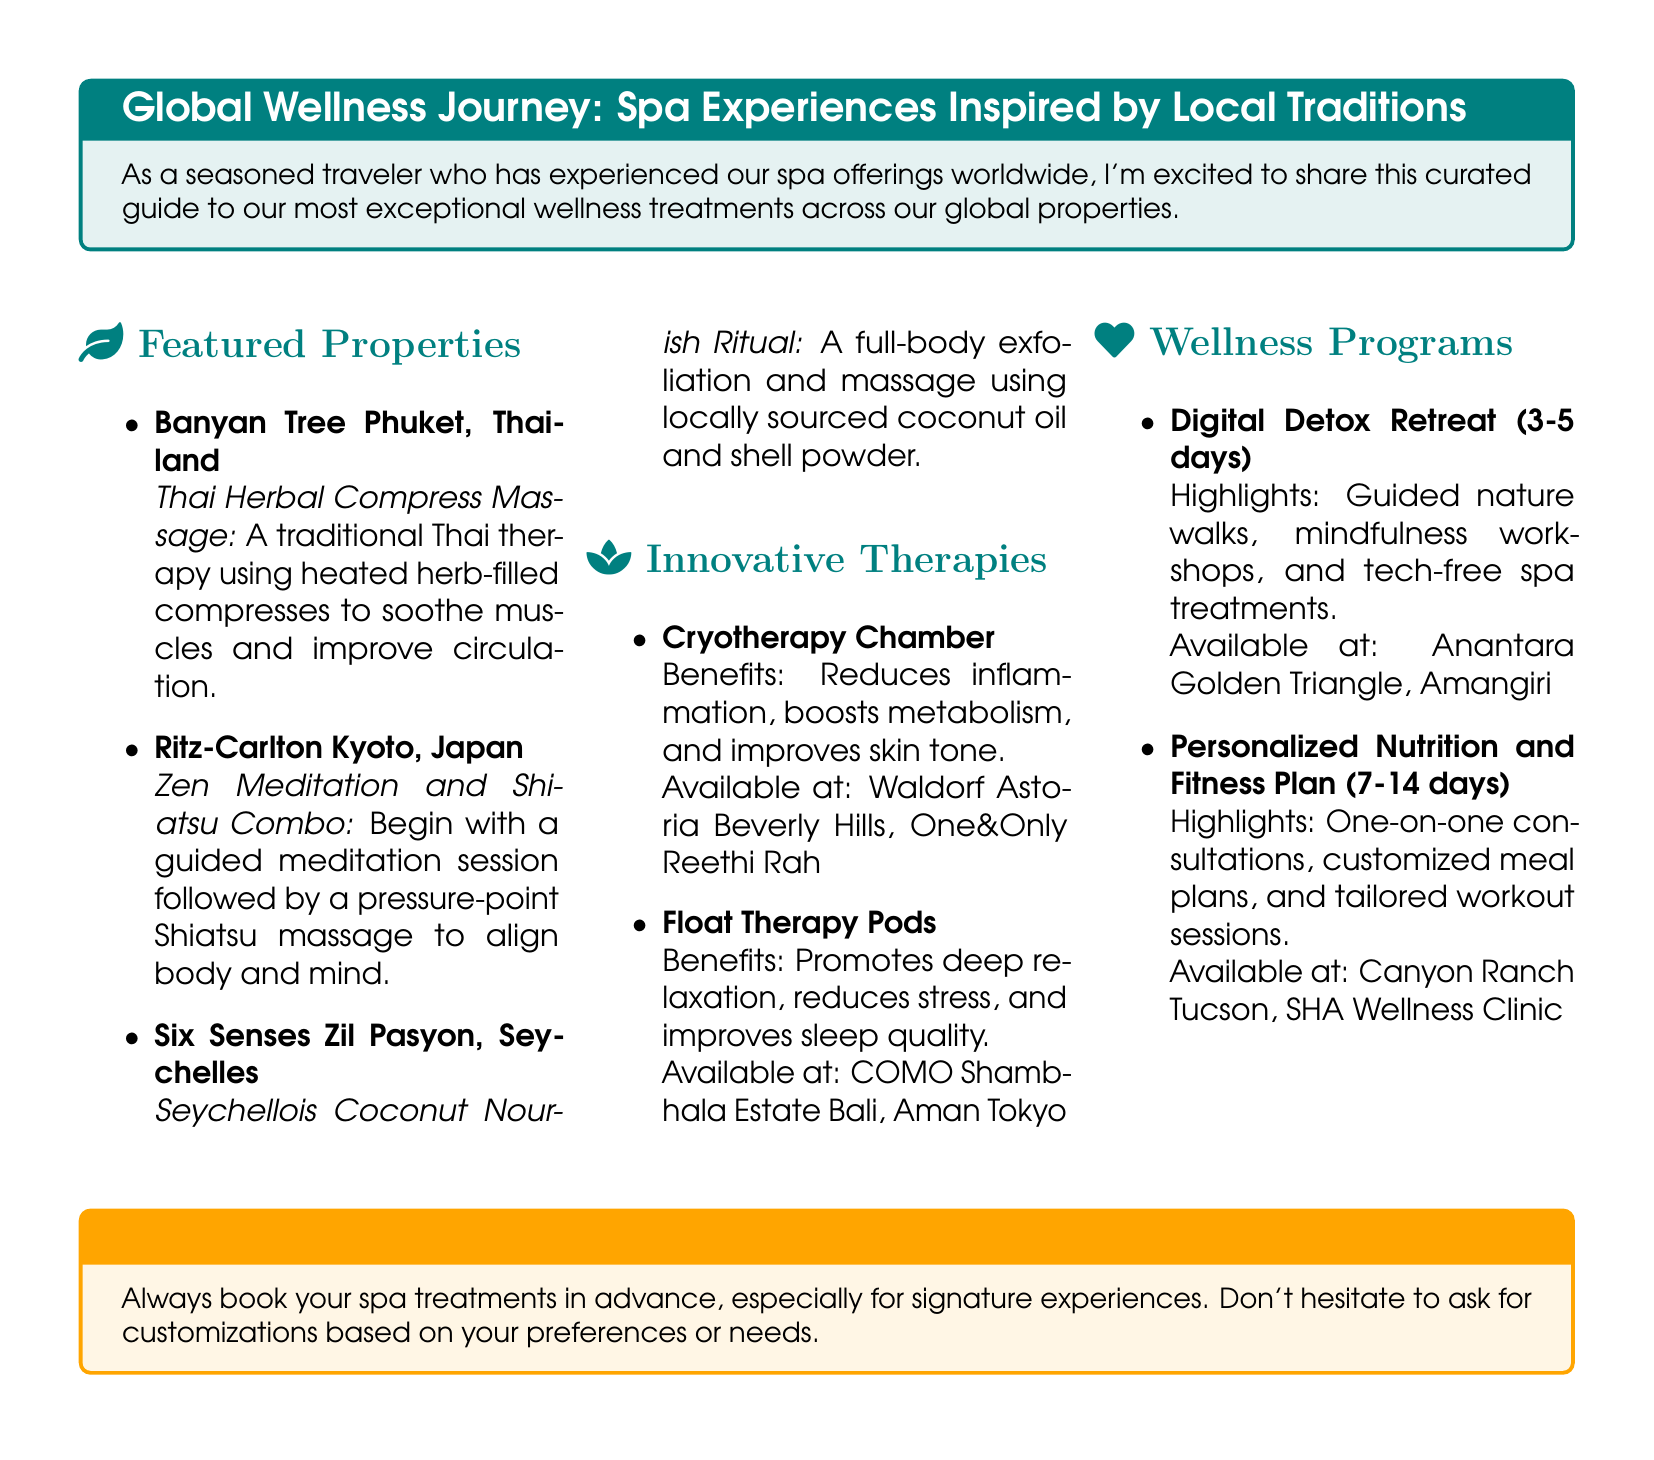What is the Thai therapy offered at Banyan Tree Phuket? The Thai therapy offered is a traditional Thai therapy using heated herb-filled compresses.
Answer: Thai Herbal Compress Massage What wellness program at Anantara Golden Triangle lasts 3-5 days? The program that lasts 3-5 days is focused on digital detox and includes guided nature walks and mindfulness workshops.
Answer: Digital Detox Retreat Which property features the Seychellois Coconut Nourish Ritual? The property featuring the Seychellois Coconut Nourish Ritual is Six Senses Zil Pasyon.
Answer: Six Senses Zil Pasyon What innovative therapy is available at Waldorf Astoria Beverly Hills? The innovative therapy available is Cryotherapy Chamber, which reduces inflammation and boosts metabolism.
Answer: Cryotherapy Chamber How long can you stay for the Personalized Nutrition and Fitness Plan? The duration for the Personalized Nutrition and Fitness Plan can be between 7 to 14 days.
Answer: 7-14 days 